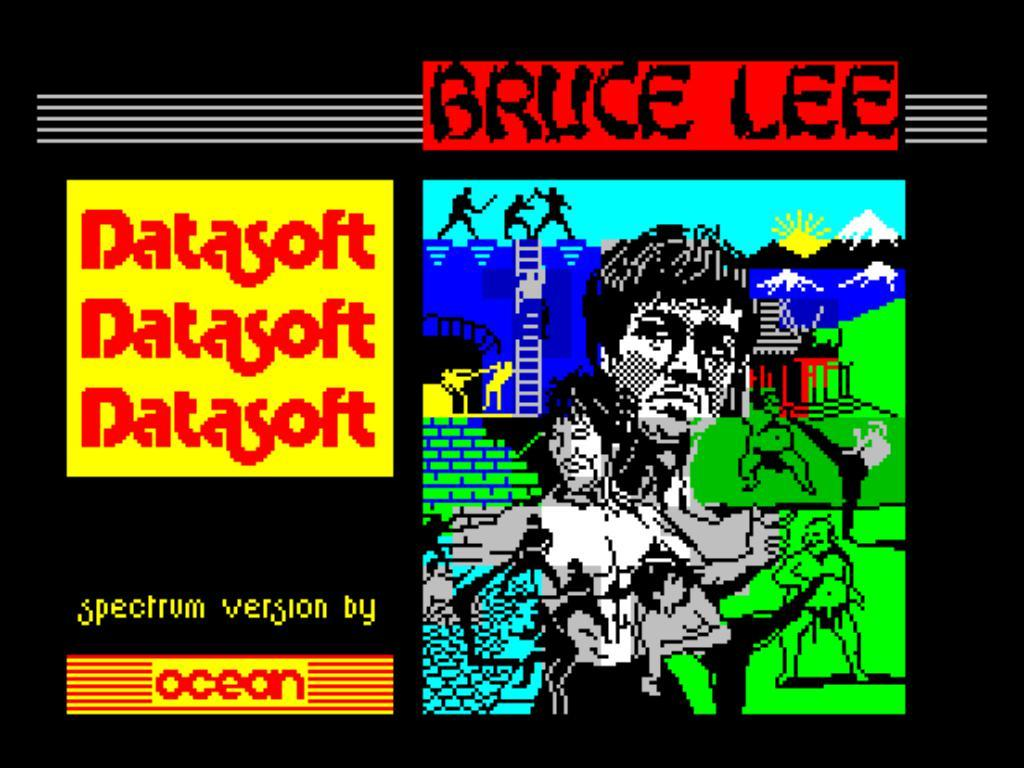<image>
Render a clear and concise summary of the photo. A Bruce Lee poster done in 8 bit by Ocean 